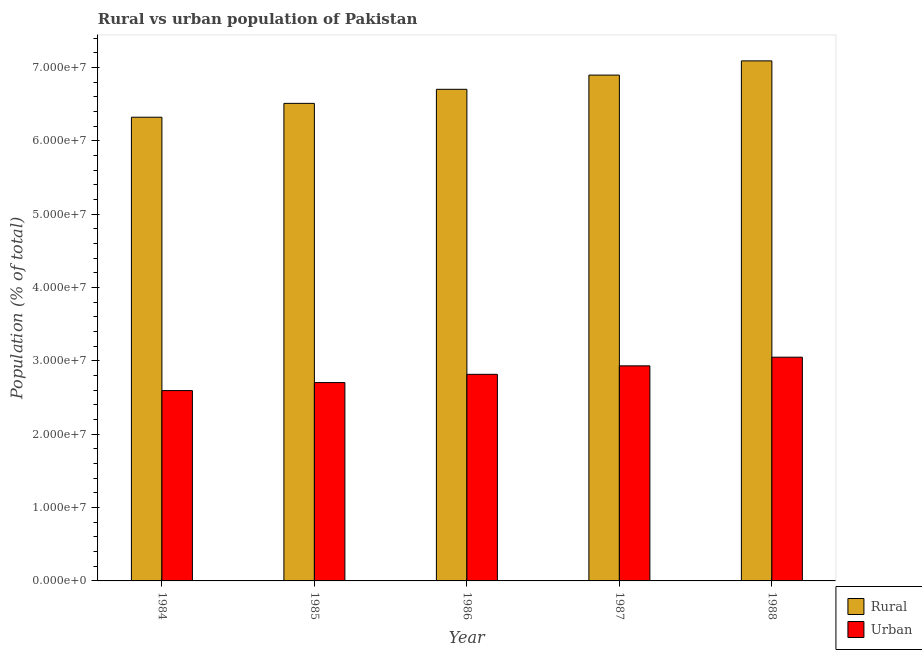How many different coloured bars are there?
Offer a terse response. 2. How many groups of bars are there?
Provide a succinct answer. 5. Are the number of bars per tick equal to the number of legend labels?
Your response must be concise. Yes. What is the label of the 5th group of bars from the left?
Provide a short and direct response. 1988. What is the rural population density in 1984?
Offer a very short reply. 6.32e+07. Across all years, what is the maximum urban population density?
Your answer should be compact. 3.05e+07. Across all years, what is the minimum urban population density?
Your answer should be very brief. 2.60e+07. In which year was the rural population density maximum?
Provide a short and direct response. 1988. In which year was the urban population density minimum?
Provide a succinct answer. 1984. What is the total rural population density in the graph?
Your answer should be very brief. 3.35e+08. What is the difference between the urban population density in 1984 and that in 1987?
Offer a very short reply. -3.37e+06. What is the difference between the rural population density in 1986 and the urban population density in 1988?
Provide a succinct answer. -3.88e+06. What is the average rural population density per year?
Your response must be concise. 6.71e+07. In how many years, is the rural population density greater than 2000000 %?
Offer a terse response. 5. What is the ratio of the urban population density in 1985 to that in 1987?
Keep it short and to the point. 0.92. What is the difference between the highest and the second highest rural population density?
Provide a short and direct response. 1.94e+06. What is the difference between the highest and the lowest rural population density?
Provide a succinct answer. 7.68e+06. In how many years, is the urban population density greater than the average urban population density taken over all years?
Give a very brief answer. 2. Is the sum of the rural population density in 1984 and 1988 greater than the maximum urban population density across all years?
Keep it short and to the point. Yes. What does the 1st bar from the left in 1987 represents?
Offer a very short reply. Rural. What does the 2nd bar from the right in 1984 represents?
Your response must be concise. Rural. Are all the bars in the graph horizontal?
Provide a succinct answer. No. What is the difference between two consecutive major ticks on the Y-axis?
Your answer should be very brief. 1.00e+07. Are the values on the major ticks of Y-axis written in scientific E-notation?
Ensure brevity in your answer.  Yes. Does the graph contain any zero values?
Give a very brief answer. No. Does the graph contain grids?
Make the answer very short. No. Where does the legend appear in the graph?
Offer a terse response. Bottom right. How many legend labels are there?
Make the answer very short. 2. How are the legend labels stacked?
Provide a short and direct response. Vertical. What is the title of the graph?
Your answer should be compact. Rural vs urban population of Pakistan. Does "Register a business" appear as one of the legend labels in the graph?
Your response must be concise. No. What is the label or title of the Y-axis?
Provide a succinct answer. Population (% of total). What is the Population (% of total) in Rural in 1984?
Offer a terse response. 6.32e+07. What is the Population (% of total) in Urban in 1984?
Provide a succinct answer. 2.60e+07. What is the Population (% of total) in Rural in 1985?
Provide a short and direct response. 6.51e+07. What is the Population (% of total) of Urban in 1985?
Give a very brief answer. 2.70e+07. What is the Population (% of total) in Rural in 1986?
Offer a terse response. 6.70e+07. What is the Population (% of total) of Urban in 1986?
Offer a terse response. 2.82e+07. What is the Population (% of total) in Rural in 1987?
Ensure brevity in your answer.  6.90e+07. What is the Population (% of total) of Urban in 1987?
Your answer should be very brief. 2.93e+07. What is the Population (% of total) of Rural in 1988?
Provide a succinct answer. 7.09e+07. What is the Population (% of total) in Urban in 1988?
Offer a very short reply. 3.05e+07. Across all years, what is the maximum Population (% of total) in Rural?
Your response must be concise. 7.09e+07. Across all years, what is the maximum Population (% of total) of Urban?
Ensure brevity in your answer.  3.05e+07. Across all years, what is the minimum Population (% of total) of Rural?
Give a very brief answer. 6.32e+07. Across all years, what is the minimum Population (% of total) in Urban?
Offer a terse response. 2.60e+07. What is the total Population (% of total) of Rural in the graph?
Offer a terse response. 3.35e+08. What is the total Population (% of total) in Urban in the graph?
Your answer should be compact. 1.41e+08. What is the difference between the Population (% of total) in Rural in 1984 and that in 1985?
Provide a succinct answer. -1.89e+06. What is the difference between the Population (% of total) of Urban in 1984 and that in 1985?
Offer a terse response. -1.09e+06. What is the difference between the Population (% of total) of Rural in 1984 and that in 1986?
Your answer should be compact. -3.81e+06. What is the difference between the Population (% of total) of Urban in 1984 and that in 1986?
Give a very brief answer. -2.22e+06. What is the difference between the Population (% of total) in Rural in 1984 and that in 1987?
Make the answer very short. -5.75e+06. What is the difference between the Population (% of total) of Urban in 1984 and that in 1987?
Provide a succinct answer. -3.37e+06. What is the difference between the Population (% of total) in Rural in 1984 and that in 1988?
Provide a succinct answer. -7.68e+06. What is the difference between the Population (% of total) of Urban in 1984 and that in 1988?
Provide a succinct answer. -4.55e+06. What is the difference between the Population (% of total) in Rural in 1985 and that in 1986?
Your response must be concise. -1.92e+06. What is the difference between the Population (% of total) in Urban in 1985 and that in 1986?
Make the answer very short. -1.12e+06. What is the difference between the Population (% of total) of Rural in 1985 and that in 1987?
Keep it short and to the point. -3.86e+06. What is the difference between the Population (% of total) of Urban in 1985 and that in 1987?
Offer a terse response. -2.28e+06. What is the difference between the Population (% of total) of Rural in 1985 and that in 1988?
Provide a short and direct response. -5.79e+06. What is the difference between the Population (% of total) of Urban in 1985 and that in 1988?
Offer a terse response. -3.46e+06. What is the difference between the Population (% of total) of Rural in 1986 and that in 1987?
Your response must be concise. -1.94e+06. What is the difference between the Population (% of total) in Urban in 1986 and that in 1987?
Keep it short and to the point. -1.16e+06. What is the difference between the Population (% of total) of Rural in 1986 and that in 1988?
Provide a succinct answer. -3.88e+06. What is the difference between the Population (% of total) of Urban in 1986 and that in 1988?
Give a very brief answer. -2.34e+06. What is the difference between the Population (% of total) in Rural in 1987 and that in 1988?
Offer a very short reply. -1.94e+06. What is the difference between the Population (% of total) in Urban in 1987 and that in 1988?
Give a very brief answer. -1.18e+06. What is the difference between the Population (% of total) in Rural in 1984 and the Population (% of total) in Urban in 1985?
Your response must be concise. 3.62e+07. What is the difference between the Population (% of total) in Rural in 1984 and the Population (% of total) in Urban in 1986?
Provide a short and direct response. 3.51e+07. What is the difference between the Population (% of total) in Rural in 1984 and the Population (% of total) in Urban in 1987?
Your response must be concise. 3.39e+07. What is the difference between the Population (% of total) of Rural in 1984 and the Population (% of total) of Urban in 1988?
Offer a terse response. 3.27e+07. What is the difference between the Population (% of total) in Rural in 1985 and the Population (% of total) in Urban in 1986?
Give a very brief answer. 3.70e+07. What is the difference between the Population (% of total) in Rural in 1985 and the Population (% of total) in Urban in 1987?
Provide a short and direct response. 3.58e+07. What is the difference between the Population (% of total) in Rural in 1985 and the Population (% of total) in Urban in 1988?
Make the answer very short. 3.46e+07. What is the difference between the Population (% of total) of Rural in 1986 and the Population (% of total) of Urban in 1987?
Offer a terse response. 3.77e+07. What is the difference between the Population (% of total) of Rural in 1986 and the Population (% of total) of Urban in 1988?
Your answer should be compact. 3.65e+07. What is the difference between the Population (% of total) in Rural in 1987 and the Population (% of total) in Urban in 1988?
Make the answer very short. 3.85e+07. What is the average Population (% of total) of Rural per year?
Provide a succinct answer. 6.71e+07. What is the average Population (% of total) in Urban per year?
Your response must be concise. 2.82e+07. In the year 1984, what is the difference between the Population (% of total) in Rural and Population (% of total) in Urban?
Give a very brief answer. 3.73e+07. In the year 1985, what is the difference between the Population (% of total) of Rural and Population (% of total) of Urban?
Offer a terse response. 3.81e+07. In the year 1986, what is the difference between the Population (% of total) of Rural and Population (% of total) of Urban?
Your response must be concise. 3.89e+07. In the year 1987, what is the difference between the Population (% of total) of Rural and Population (% of total) of Urban?
Provide a short and direct response. 3.96e+07. In the year 1988, what is the difference between the Population (% of total) in Rural and Population (% of total) in Urban?
Give a very brief answer. 4.04e+07. What is the ratio of the Population (% of total) in Urban in 1984 to that in 1985?
Provide a succinct answer. 0.96. What is the ratio of the Population (% of total) in Rural in 1984 to that in 1986?
Your answer should be very brief. 0.94. What is the ratio of the Population (% of total) in Urban in 1984 to that in 1986?
Provide a short and direct response. 0.92. What is the ratio of the Population (% of total) in Rural in 1984 to that in 1987?
Make the answer very short. 0.92. What is the ratio of the Population (% of total) in Urban in 1984 to that in 1987?
Your answer should be compact. 0.89. What is the ratio of the Population (% of total) in Rural in 1984 to that in 1988?
Keep it short and to the point. 0.89. What is the ratio of the Population (% of total) in Urban in 1984 to that in 1988?
Your response must be concise. 0.85. What is the ratio of the Population (% of total) in Rural in 1985 to that in 1986?
Keep it short and to the point. 0.97. What is the ratio of the Population (% of total) of Urban in 1985 to that in 1986?
Provide a succinct answer. 0.96. What is the ratio of the Population (% of total) in Rural in 1985 to that in 1987?
Make the answer very short. 0.94. What is the ratio of the Population (% of total) of Urban in 1985 to that in 1987?
Offer a terse response. 0.92. What is the ratio of the Population (% of total) of Rural in 1985 to that in 1988?
Provide a short and direct response. 0.92. What is the ratio of the Population (% of total) of Urban in 1985 to that in 1988?
Offer a very short reply. 0.89. What is the ratio of the Population (% of total) of Rural in 1986 to that in 1987?
Keep it short and to the point. 0.97. What is the ratio of the Population (% of total) in Urban in 1986 to that in 1987?
Offer a terse response. 0.96. What is the ratio of the Population (% of total) of Rural in 1986 to that in 1988?
Give a very brief answer. 0.95. What is the ratio of the Population (% of total) of Urban in 1986 to that in 1988?
Your answer should be very brief. 0.92. What is the ratio of the Population (% of total) of Rural in 1987 to that in 1988?
Keep it short and to the point. 0.97. What is the ratio of the Population (% of total) of Urban in 1987 to that in 1988?
Your answer should be compact. 0.96. What is the difference between the highest and the second highest Population (% of total) in Rural?
Offer a very short reply. 1.94e+06. What is the difference between the highest and the second highest Population (% of total) in Urban?
Your answer should be compact. 1.18e+06. What is the difference between the highest and the lowest Population (% of total) in Rural?
Give a very brief answer. 7.68e+06. What is the difference between the highest and the lowest Population (% of total) of Urban?
Offer a terse response. 4.55e+06. 